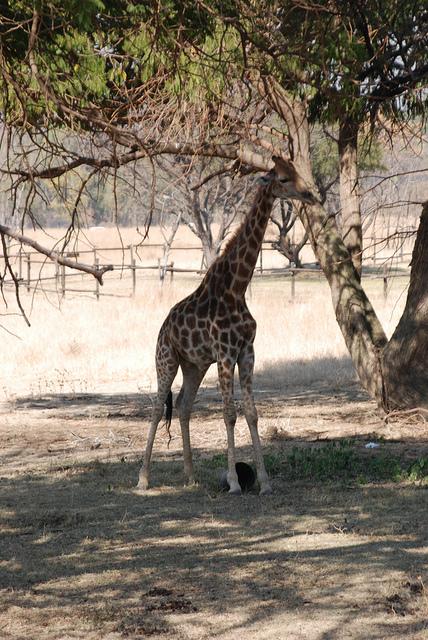Is this animal alone?
Short answer required. Yes. Has this animal reached maturity?
Concise answer only. No. Does this animal have a tail?
Concise answer only. Yes. 